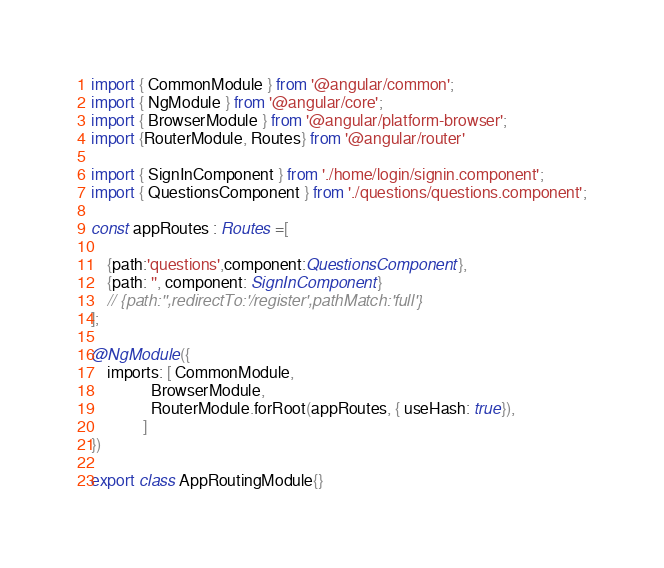<code> <loc_0><loc_0><loc_500><loc_500><_TypeScript_>import { CommonModule } from '@angular/common';
import { NgModule } from '@angular/core';
import { BrowserModule } from '@angular/platform-browser';
import {RouterModule, Routes} from '@angular/router'

import { SignInComponent } from './home/login/signin.component';
import { QuestionsComponent } from './questions/questions.component';

const appRoutes : Routes =[
    
    {path:'questions',component:QuestionsComponent},
    {path: '', component: SignInComponent}
    // {path:'',redirectTo:'/register',pathMatch:'full'}
];

@NgModule({
    imports: [ CommonModule,  
               BrowserModule, 
               RouterModule.forRoot(appRoutes, { useHash: true}),
             ]
})

export class AppRoutingModule{}</code> 